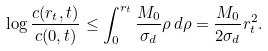<formula> <loc_0><loc_0><loc_500><loc_500>\log \frac { c ( r _ { t } , t ) } { c ( 0 , t ) } \leq \int _ { 0 } ^ { r _ { t } } \frac { M _ { 0 } } { \sigma _ { d } } \rho \, d \rho = \frac { M _ { 0 } } { 2 \sigma _ { d } } r _ { t } ^ { 2 } .</formula> 